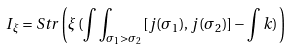<formula> <loc_0><loc_0><loc_500><loc_500>I _ { \xi } = S t r \left ( \xi \, ( \int \int _ { \sigma _ { 1 } > \sigma _ { 2 } } [ j ( \sigma _ { 1 } ) , j ( \sigma _ { 2 } ) ] - \int k ) \, \right )</formula> 